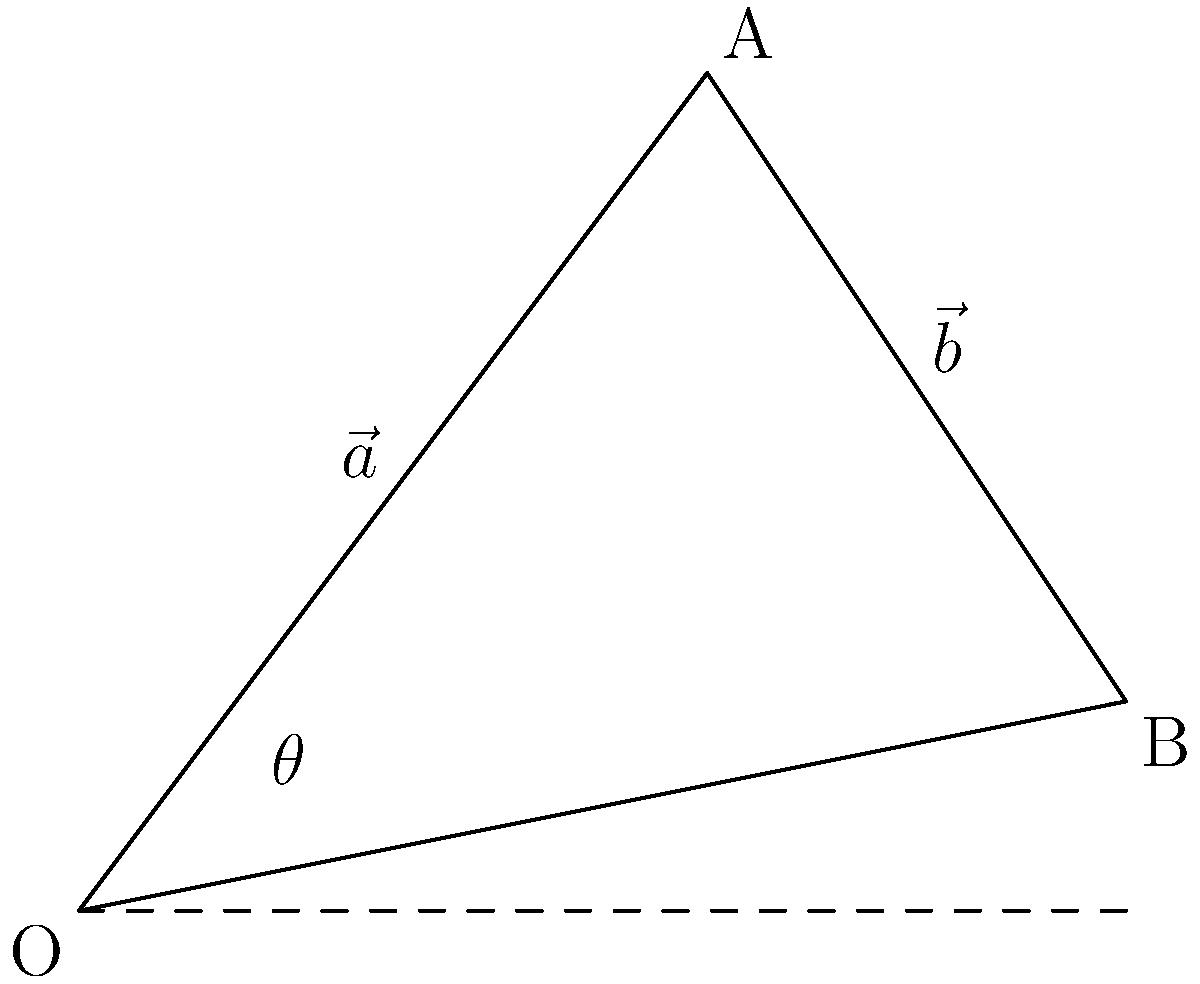In analyzing the boundary shifts of a North Carolina electoral district, you've represented two consecutive changes as vectors $\vec{a}$ and $\vec{b}$. Vector $\vec{a}$ has components (3, 4), and vector $\vec{b}$ has components (5, 1). What is the angle $\theta$ between these two vectors, rounded to the nearest degree? To find the angle between two vectors, we can use the dot product formula:

$$\cos \theta = \frac{\vec{a} \cdot \vec{b}}{|\vec{a}||\vec{b}|}$$

Step 1: Calculate the dot product $\vec{a} \cdot \vec{b}$
$\vec{a} \cdot \vec{b} = (3 \times 5) + (4 \times 1) = 15 + 4 = 19$

Step 2: Calculate the magnitudes of $\vec{a}$ and $\vec{b}$
$|\vec{a}| = \sqrt{3^2 + 4^2} = \sqrt{9 + 16} = \sqrt{25} = 5$
$|\vec{b}| = \sqrt{5^2 + 1^2} = \sqrt{25 + 1} = \sqrt{26}$

Step 3: Apply the dot product formula
$$\cos \theta = \frac{19}{5\sqrt{26}}$$

Step 4: Take the inverse cosine (arccos) of both sides
$$\theta = \arccos(\frac{19}{5\sqrt{26}})$$

Step 5: Calculate and round to the nearest degree
$$\theta \approx 41.4°$$

Rounding to the nearest degree gives us 41°.
Answer: 41° 